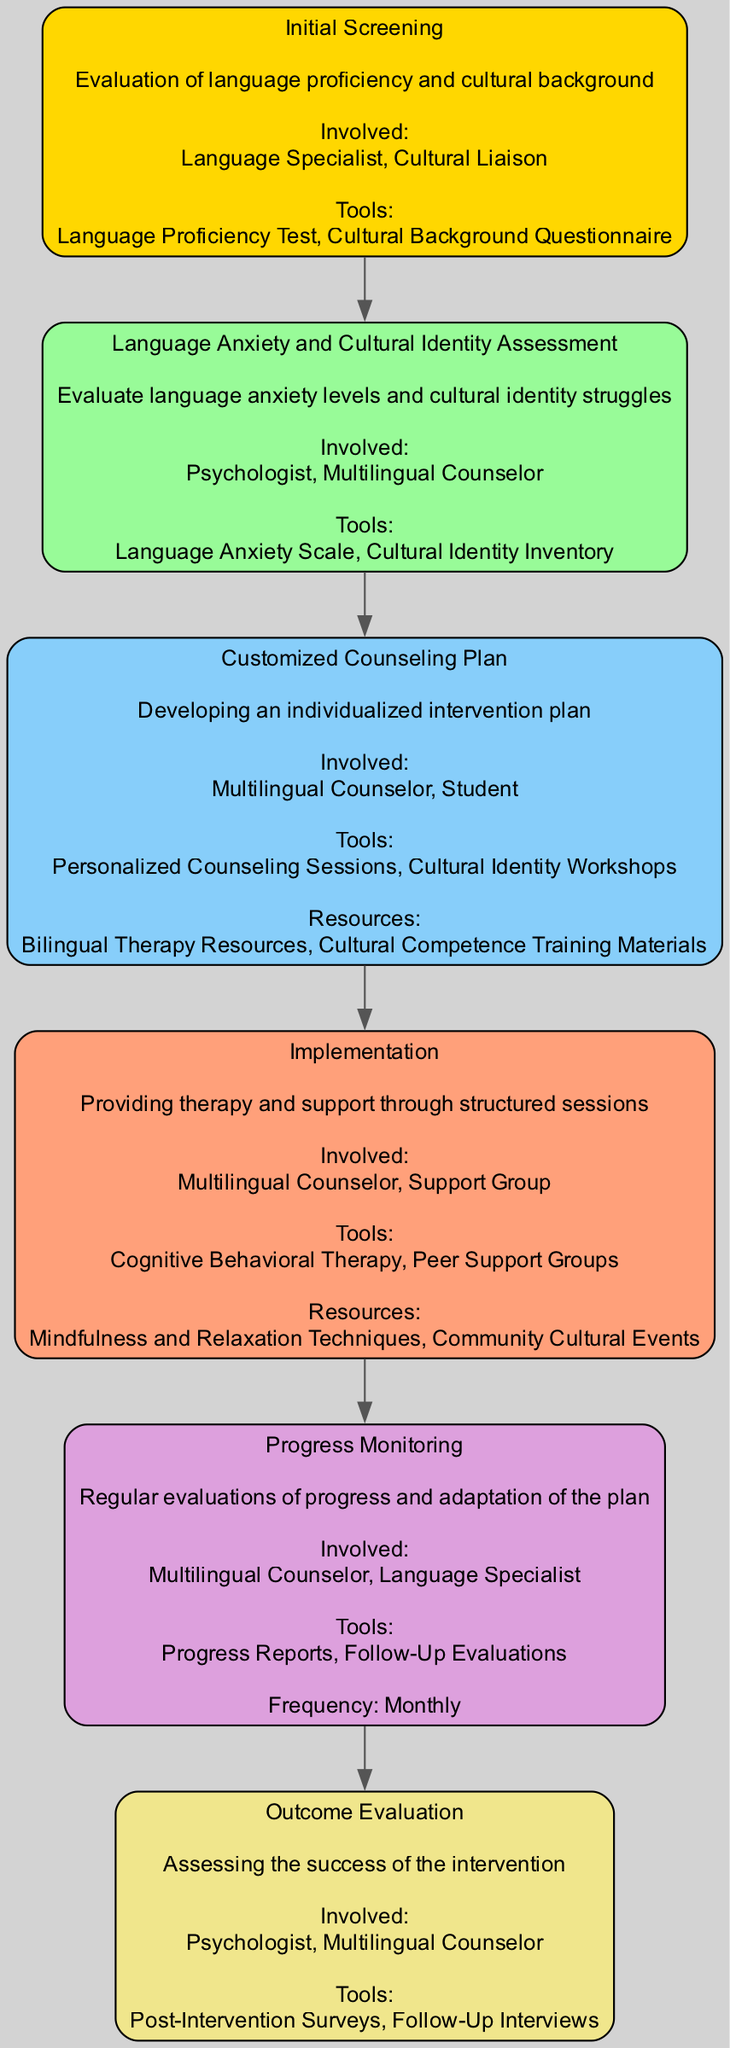What is the first step in the Clinical Pathway? The first step is identified as "Initial Screening", which is clearly shown at the top of the diagram as the starting point of the pathway.
Answer: Initial Screening How many tools are used in the Intervention Plan step? The Intervention Plan step lists two tools in the diagram: "Personalized Counseling Sessions" and "Cultural Identity Workshops".
Answer: 2 Who is involved in the Follow-Up step? The Follow-Up step designates two involved parties: "Multilingual Counselor" and "Language Specialist", which are indicated in that section of the diagram.
Answer: Multilingual Counselor, Language Specialist What is the frequency of the Follow-Up evaluations? The diagram specifies that the Follow-Up evaluations occur on a "Monthly" basis, which is explicitly mentioned in that section.
Answer: Monthly Which step comes after the Language Anxiety and Cultural Identity Assessment? Following the Language Anxiety and Cultural Identity Assessment step, the next step in the pathway is the "Customized Counseling Plan", as shown by the directional flow in the diagram.
Answer: Customized Counseling Plan What tools are used in the Implementation step? The Implementation step utilizes two tools: "Cognitive Behavioral Therapy" and "Peer Support Groups", as clearly listed under that step in the diagram.
Answer: Cognitive Behavioral Therapy, Peer Support Groups How is success assessed in the Clinical Pathway? Success is assessed in the final step titled "Outcome Evaluation", which is identified in the diagram where post-intervention assessment activities are performed.
Answer: Outcome Evaluation What type of assessment is conducted in the second step? The second step focuses on "Language Anxiety and Cultural Identity Assessment", stating its purpose in evaluating anxiety and identity struggles within this pathway.
Answer: Language Anxiety and Cultural Identity Assessment What resources are provided in the Intervention Plan? The Intervention Plan lists two resources: "Bilingual Therapy Resources" and "Cultural Competence Training Materials", presented as supporting components in the diagram.
Answer: Bilingual Therapy Resources, Cultural Competence Training Materials 